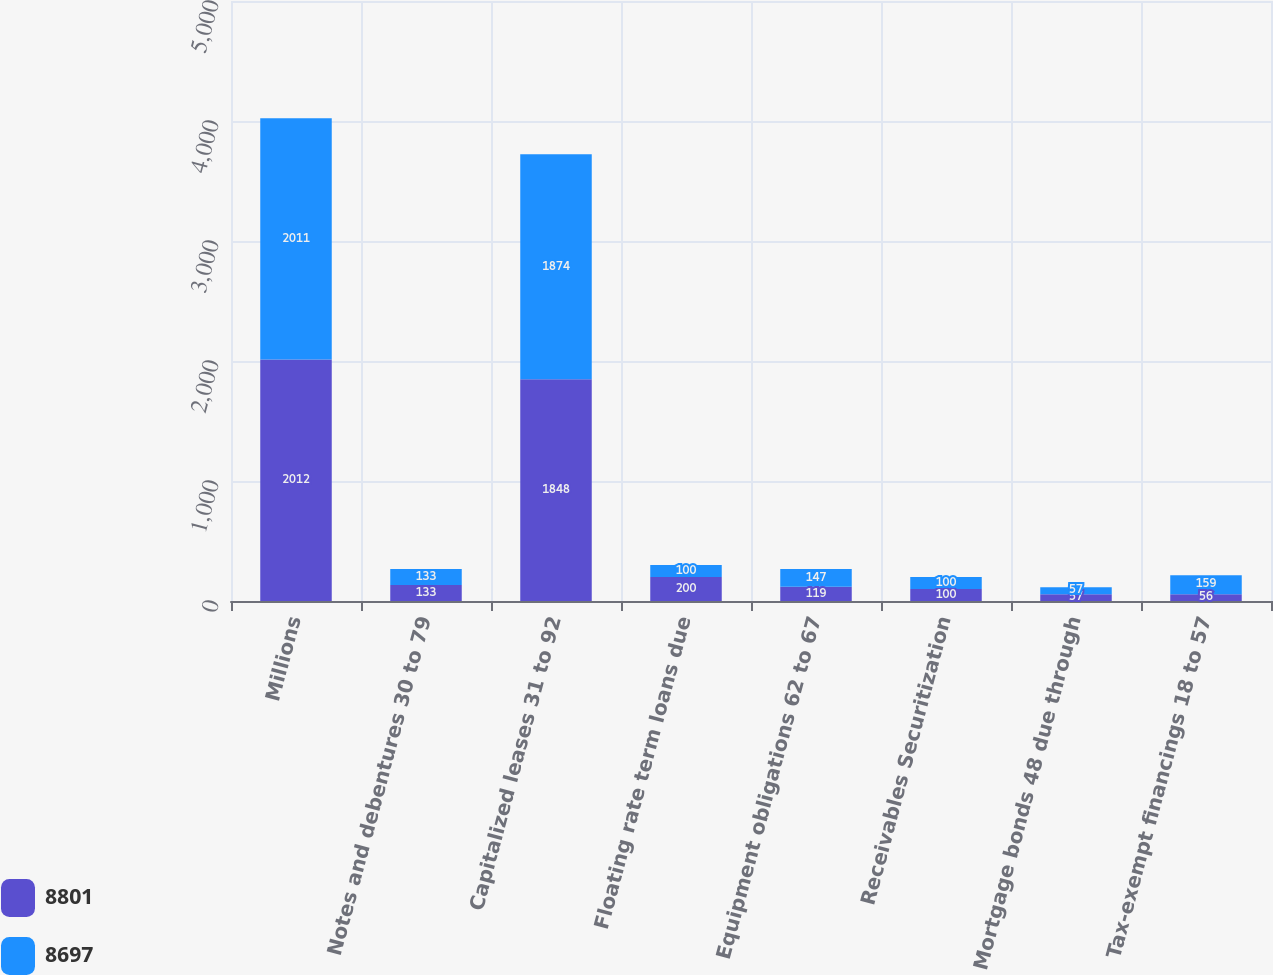<chart> <loc_0><loc_0><loc_500><loc_500><stacked_bar_chart><ecel><fcel>Millions<fcel>Notes and debentures 30 to 79<fcel>Capitalized leases 31 to 92<fcel>Floating rate term loans due<fcel>Equipment obligations 62 to 67<fcel>Receivables Securitization<fcel>Mortgage bonds 48 due through<fcel>Tax-exempt financings 18 to 57<nl><fcel>8801<fcel>2012<fcel>133<fcel>1848<fcel>200<fcel>119<fcel>100<fcel>57<fcel>56<nl><fcel>8697<fcel>2011<fcel>133<fcel>1874<fcel>100<fcel>147<fcel>100<fcel>57<fcel>159<nl></chart> 